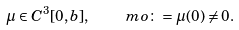<formula> <loc_0><loc_0><loc_500><loc_500>\mu \in C ^ { 3 } [ 0 , b ] , \quad \ m o \colon = \mu ( 0 ) \neq 0 .</formula> 